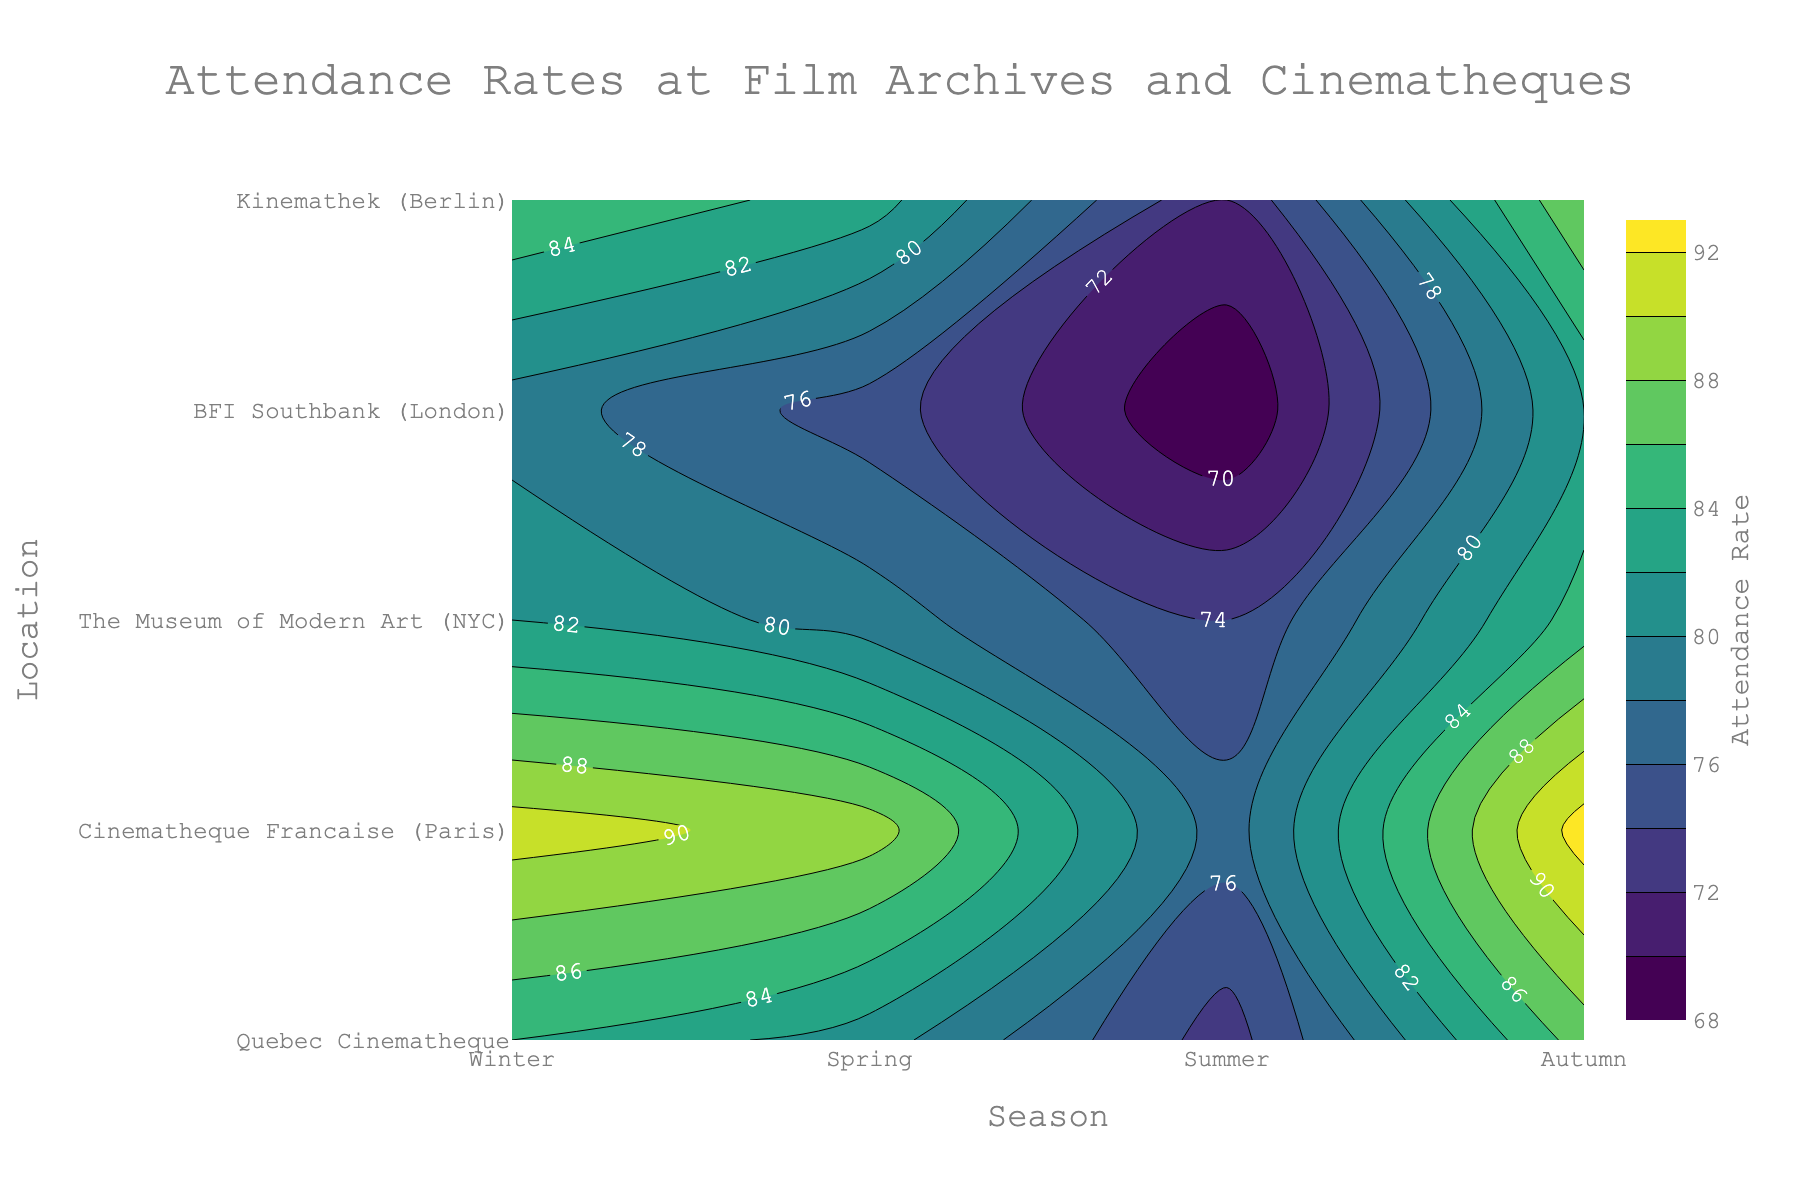What's the highest attendance rate displayed and in which location and season does it occur? Look for the highest contour label reading and locate its corresponding position on the x (Season) and y (Location) axes. The highest rate is labeled 93, occurring in Winter at the Cinematheque Francaise (Paris).
Answer: 93, Cinematheque Francaise, Winter What is the overall trend of attendance rates at Quebec Cinematheque across different seasons? Trace the contour labels through the seasons for the Quebec Cinematheque. It reads 82 (Winter), 75 (Spring), 68 (Summer), and 79 (Autumn). The trend shows attendance is highest in Winter, drops in Spring and Summer, then rises again in Autumn.
Answer: Goes down in Spring and Summer, then rises in Autumn Which season has the lowest overall attendance rates across all locations? Examine the contour labels across different locations for each season. Summer shows the lowest attendance rates, with readings of 68, 77, 72, 73, and 74.
Answer: Summer How does attendance in Autumn at BFI Southbank compare with Spring attendance at BFI Southbank? Compare the contour label readings for BFI Southbank between Autumn (84) and Spring (81). Autumn has a higher attendance rate than Spring by 3.
Answer: Autumn is higher by 3 What is the average attendance rate for all locations in Spring? Sum the contour labels for Spring (75, 89, 83, 81, 79) and divide by the number of locations (5). (75 + 89 + 83 + 81 + 79) / 5 = 81.4
Answer: 81.4 Is attendance at Kinemathek higher in Winter or Autumn? Compare the contour label readings for Kinemathek between Winter (85) and Autumn (82). Winter has a higher attendance rate than Autumn by 3.
Answer: Winter is higher by 3 Which location has the most variation in attendance rate across different seasons? Compare the range of attendance rates for each location. Quebec Cinematheque ranges from 68 to 82 (14 points), Cinematheque Francaise ranges from 77 to 93 (16 points), The Museum of Modern Art from 72 to 88 (16 points), BFI Southbank from 73 to 87 (14 points), and Kinemathek from 74 to 85 (11 points). Both Cinematheque Francaise and The Museum of Modern Art have the most variation at 16 points.
Answer: Cinematheque Francaise and The Museum of Modern Art What is the difference in attendance rates between Winter and Summer at The Museum of Modern Art? Find the contour label readings for The Museum of Modern Art in Winter (88) and Summer (72), and subtract the Summer rate from the Winter rate. 88 - 72 = 16.
Answer: 16 